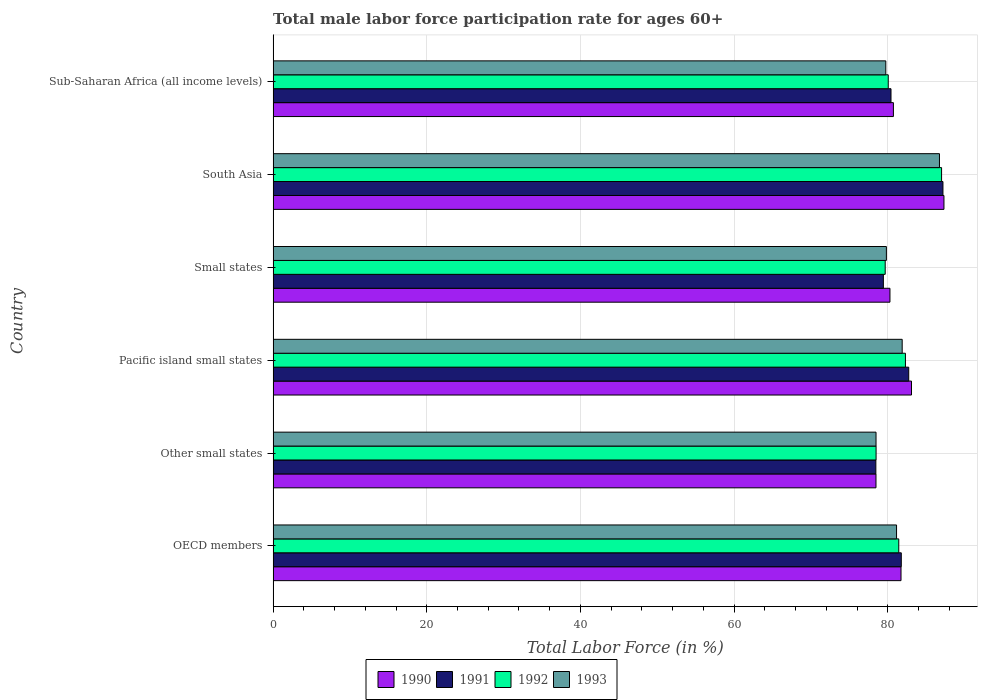How many groups of bars are there?
Provide a short and direct response. 6. Are the number of bars on each tick of the Y-axis equal?
Offer a very short reply. Yes. How many bars are there on the 5th tick from the top?
Make the answer very short. 4. How many bars are there on the 4th tick from the bottom?
Provide a short and direct response. 4. What is the male labor force participation rate in 1990 in Small states?
Keep it short and to the point. 80.28. Across all countries, what is the maximum male labor force participation rate in 1991?
Provide a short and direct response. 87.18. Across all countries, what is the minimum male labor force participation rate in 1992?
Keep it short and to the point. 78.48. In which country was the male labor force participation rate in 1993 maximum?
Offer a very short reply. South Asia. In which country was the male labor force participation rate in 1993 minimum?
Provide a succinct answer. Other small states. What is the total male labor force participation rate in 1991 in the graph?
Give a very brief answer. 489.96. What is the difference between the male labor force participation rate in 1991 in Other small states and that in Small states?
Your response must be concise. -0.98. What is the difference between the male labor force participation rate in 1993 in OECD members and the male labor force participation rate in 1991 in Small states?
Ensure brevity in your answer.  1.71. What is the average male labor force participation rate in 1991 per country?
Offer a terse response. 81.66. What is the difference between the male labor force participation rate in 1991 and male labor force participation rate in 1990 in Other small states?
Keep it short and to the point. -0.02. What is the ratio of the male labor force participation rate in 1993 in Pacific island small states to that in South Asia?
Offer a terse response. 0.94. Is the difference between the male labor force participation rate in 1991 in Other small states and Pacific island small states greater than the difference between the male labor force participation rate in 1990 in Other small states and Pacific island small states?
Give a very brief answer. Yes. What is the difference between the highest and the second highest male labor force participation rate in 1990?
Offer a terse response. 4.22. What is the difference between the highest and the lowest male labor force participation rate in 1991?
Make the answer very short. 8.73. In how many countries, is the male labor force participation rate in 1992 greater than the average male labor force participation rate in 1992 taken over all countries?
Ensure brevity in your answer.  2. Is the sum of the male labor force participation rate in 1990 in Other small states and South Asia greater than the maximum male labor force participation rate in 1991 across all countries?
Your answer should be very brief. Yes. Is it the case that in every country, the sum of the male labor force participation rate in 1992 and male labor force participation rate in 1991 is greater than the sum of male labor force participation rate in 1993 and male labor force participation rate in 1990?
Make the answer very short. No. Is it the case that in every country, the sum of the male labor force participation rate in 1991 and male labor force participation rate in 1990 is greater than the male labor force participation rate in 1993?
Give a very brief answer. Yes. What is the difference between two consecutive major ticks on the X-axis?
Keep it short and to the point. 20. Does the graph contain grids?
Ensure brevity in your answer.  Yes. Where does the legend appear in the graph?
Your response must be concise. Bottom center. How many legend labels are there?
Provide a succinct answer. 4. How are the legend labels stacked?
Your answer should be compact. Horizontal. What is the title of the graph?
Your response must be concise. Total male labor force participation rate for ages 60+. Does "1998" appear as one of the legend labels in the graph?
Your answer should be very brief. No. What is the label or title of the X-axis?
Offer a very short reply. Total Labor Force (in %). What is the label or title of the Y-axis?
Your answer should be compact. Country. What is the Total Labor Force (in %) of 1990 in OECD members?
Make the answer very short. 81.72. What is the Total Labor Force (in %) of 1991 in OECD members?
Offer a terse response. 81.76. What is the Total Labor Force (in %) of 1992 in OECD members?
Offer a terse response. 81.43. What is the Total Labor Force (in %) in 1993 in OECD members?
Offer a terse response. 81.14. What is the Total Labor Force (in %) in 1990 in Other small states?
Provide a succinct answer. 78.46. What is the Total Labor Force (in %) of 1991 in Other small states?
Provide a short and direct response. 78.45. What is the Total Labor Force (in %) in 1992 in Other small states?
Give a very brief answer. 78.48. What is the Total Labor Force (in %) of 1993 in Other small states?
Your answer should be very brief. 78.47. What is the Total Labor Force (in %) in 1990 in Pacific island small states?
Your answer should be compact. 83.09. What is the Total Labor Force (in %) in 1991 in Pacific island small states?
Your response must be concise. 82.72. What is the Total Labor Force (in %) of 1992 in Pacific island small states?
Ensure brevity in your answer.  82.3. What is the Total Labor Force (in %) of 1993 in Pacific island small states?
Offer a terse response. 81.87. What is the Total Labor Force (in %) in 1990 in Small states?
Your answer should be very brief. 80.28. What is the Total Labor Force (in %) in 1991 in Small states?
Give a very brief answer. 79.43. What is the Total Labor Force (in %) of 1992 in Small states?
Offer a very short reply. 79.66. What is the Total Labor Force (in %) of 1993 in Small states?
Give a very brief answer. 79.82. What is the Total Labor Force (in %) of 1990 in South Asia?
Your response must be concise. 87.31. What is the Total Labor Force (in %) in 1991 in South Asia?
Make the answer very short. 87.18. What is the Total Labor Force (in %) of 1992 in South Asia?
Ensure brevity in your answer.  87. What is the Total Labor Force (in %) of 1993 in South Asia?
Your answer should be very brief. 86.73. What is the Total Labor Force (in %) in 1990 in Sub-Saharan Africa (all income levels)?
Offer a terse response. 80.73. What is the Total Labor Force (in %) in 1991 in Sub-Saharan Africa (all income levels)?
Offer a very short reply. 80.42. What is the Total Labor Force (in %) in 1992 in Sub-Saharan Africa (all income levels)?
Offer a terse response. 80.06. What is the Total Labor Force (in %) in 1993 in Sub-Saharan Africa (all income levels)?
Offer a very short reply. 79.74. Across all countries, what is the maximum Total Labor Force (in %) in 1990?
Give a very brief answer. 87.31. Across all countries, what is the maximum Total Labor Force (in %) of 1991?
Provide a short and direct response. 87.18. Across all countries, what is the maximum Total Labor Force (in %) in 1992?
Give a very brief answer. 87. Across all countries, what is the maximum Total Labor Force (in %) in 1993?
Ensure brevity in your answer.  86.73. Across all countries, what is the minimum Total Labor Force (in %) in 1990?
Give a very brief answer. 78.46. Across all countries, what is the minimum Total Labor Force (in %) of 1991?
Give a very brief answer. 78.45. Across all countries, what is the minimum Total Labor Force (in %) of 1992?
Offer a very short reply. 78.48. Across all countries, what is the minimum Total Labor Force (in %) in 1993?
Make the answer very short. 78.47. What is the total Total Labor Force (in %) in 1990 in the graph?
Ensure brevity in your answer.  491.6. What is the total Total Labor Force (in %) of 1991 in the graph?
Provide a short and direct response. 489.96. What is the total Total Labor Force (in %) in 1992 in the graph?
Your answer should be compact. 488.93. What is the total Total Labor Force (in %) of 1993 in the graph?
Ensure brevity in your answer.  487.77. What is the difference between the Total Labor Force (in %) in 1990 in OECD members and that in Other small states?
Ensure brevity in your answer.  3.26. What is the difference between the Total Labor Force (in %) of 1991 in OECD members and that in Other small states?
Provide a short and direct response. 3.31. What is the difference between the Total Labor Force (in %) of 1992 in OECD members and that in Other small states?
Provide a short and direct response. 2.95. What is the difference between the Total Labor Force (in %) in 1993 in OECD members and that in Other small states?
Offer a very short reply. 2.67. What is the difference between the Total Labor Force (in %) of 1990 in OECD members and that in Pacific island small states?
Provide a succinct answer. -1.36. What is the difference between the Total Labor Force (in %) in 1991 in OECD members and that in Pacific island small states?
Your answer should be very brief. -0.97. What is the difference between the Total Labor Force (in %) of 1992 in OECD members and that in Pacific island small states?
Make the answer very short. -0.87. What is the difference between the Total Labor Force (in %) of 1993 in OECD members and that in Pacific island small states?
Keep it short and to the point. -0.73. What is the difference between the Total Labor Force (in %) of 1990 in OECD members and that in Small states?
Offer a very short reply. 1.44. What is the difference between the Total Labor Force (in %) in 1991 in OECD members and that in Small states?
Keep it short and to the point. 2.33. What is the difference between the Total Labor Force (in %) in 1992 in OECD members and that in Small states?
Offer a terse response. 1.77. What is the difference between the Total Labor Force (in %) of 1993 in OECD members and that in Small states?
Your answer should be compact. 1.32. What is the difference between the Total Labor Force (in %) of 1990 in OECD members and that in South Asia?
Ensure brevity in your answer.  -5.59. What is the difference between the Total Labor Force (in %) of 1991 in OECD members and that in South Asia?
Your response must be concise. -5.42. What is the difference between the Total Labor Force (in %) of 1992 in OECD members and that in South Asia?
Your answer should be compact. -5.57. What is the difference between the Total Labor Force (in %) of 1993 in OECD members and that in South Asia?
Offer a terse response. -5.59. What is the difference between the Total Labor Force (in %) of 1990 in OECD members and that in Sub-Saharan Africa (all income levels)?
Your answer should be very brief. 0.99. What is the difference between the Total Labor Force (in %) of 1991 in OECD members and that in Sub-Saharan Africa (all income levels)?
Give a very brief answer. 1.34. What is the difference between the Total Labor Force (in %) of 1992 in OECD members and that in Sub-Saharan Africa (all income levels)?
Keep it short and to the point. 1.37. What is the difference between the Total Labor Force (in %) of 1993 in OECD members and that in Sub-Saharan Africa (all income levels)?
Your answer should be compact. 1.4. What is the difference between the Total Labor Force (in %) of 1990 in Other small states and that in Pacific island small states?
Provide a short and direct response. -4.62. What is the difference between the Total Labor Force (in %) of 1991 in Other small states and that in Pacific island small states?
Offer a terse response. -4.28. What is the difference between the Total Labor Force (in %) in 1992 in Other small states and that in Pacific island small states?
Your answer should be compact. -3.82. What is the difference between the Total Labor Force (in %) in 1993 in Other small states and that in Pacific island small states?
Make the answer very short. -3.4. What is the difference between the Total Labor Force (in %) of 1990 in Other small states and that in Small states?
Your answer should be compact. -1.82. What is the difference between the Total Labor Force (in %) in 1991 in Other small states and that in Small states?
Offer a terse response. -0.98. What is the difference between the Total Labor Force (in %) in 1992 in Other small states and that in Small states?
Offer a very short reply. -1.19. What is the difference between the Total Labor Force (in %) of 1993 in Other small states and that in Small states?
Give a very brief answer. -1.35. What is the difference between the Total Labor Force (in %) in 1990 in Other small states and that in South Asia?
Your answer should be compact. -8.85. What is the difference between the Total Labor Force (in %) in 1991 in Other small states and that in South Asia?
Give a very brief answer. -8.73. What is the difference between the Total Labor Force (in %) of 1992 in Other small states and that in South Asia?
Your answer should be compact. -8.52. What is the difference between the Total Labor Force (in %) of 1993 in Other small states and that in South Asia?
Give a very brief answer. -8.26. What is the difference between the Total Labor Force (in %) in 1990 in Other small states and that in Sub-Saharan Africa (all income levels)?
Offer a very short reply. -2.27. What is the difference between the Total Labor Force (in %) of 1991 in Other small states and that in Sub-Saharan Africa (all income levels)?
Offer a very short reply. -1.97. What is the difference between the Total Labor Force (in %) in 1992 in Other small states and that in Sub-Saharan Africa (all income levels)?
Provide a succinct answer. -1.58. What is the difference between the Total Labor Force (in %) of 1993 in Other small states and that in Sub-Saharan Africa (all income levels)?
Keep it short and to the point. -1.27. What is the difference between the Total Labor Force (in %) of 1990 in Pacific island small states and that in Small states?
Provide a short and direct response. 2.8. What is the difference between the Total Labor Force (in %) in 1991 in Pacific island small states and that in Small states?
Ensure brevity in your answer.  3.3. What is the difference between the Total Labor Force (in %) of 1992 in Pacific island small states and that in Small states?
Ensure brevity in your answer.  2.63. What is the difference between the Total Labor Force (in %) in 1993 in Pacific island small states and that in Small states?
Keep it short and to the point. 2.05. What is the difference between the Total Labor Force (in %) of 1990 in Pacific island small states and that in South Asia?
Provide a short and direct response. -4.22. What is the difference between the Total Labor Force (in %) in 1991 in Pacific island small states and that in South Asia?
Give a very brief answer. -4.46. What is the difference between the Total Labor Force (in %) in 1992 in Pacific island small states and that in South Asia?
Offer a terse response. -4.7. What is the difference between the Total Labor Force (in %) of 1993 in Pacific island small states and that in South Asia?
Ensure brevity in your answer.  -4.85. What is the difference between the Total Labor Force (in %) of 1990 in Pacific island small states and that in Sub-Saharan Africa (all income levels)?
Offer a very short reply. 2.35. What is the difference between the Total Labor Force (in %) in 1991 in Pacific island small states and that in Sub-Saharan Africa (all income levels)?
Offer a very short reply. 2.31. What is the difference between the Total Labor Force (in %) in 1992 in Pacific island small states and that in Sub-Saharan Africa (all income levels)?
Give a very brief answer. 2.24. What is the difference between the Total Labor Force (in %) in 1993 in Pacific island small states and that in Sub-Saharan Africa (all income levels)?
Make the answer very short. 2.13. What is the difference between the Total Labor Force (in %) of 1990 in Small states and that in South Asia?
Your answer should be compact. -7.03. What is the difference between the Total Labor Force (in %) in 1991 in Small states and that in South Asia?
Your answer should be very brief. -7.75. What is the difference between the Total Labor Force (in %) in 1992 in Small states and that in South Asia?
Offer a very short reply. -7.34. What is the difference between the Total Labor Force (in %) of 1993 in Small states and that in South Asia?
Offer a very short reply. -6.91. What is the difference between the Total Labor Force (in %) in 1990 in Small states and that in Sub-Saharan Africa (all income levels)?
Keep it short and to the point. -0.45. What is the difference between the Total Labor Force (in %) in 1991 in Small states and that in Sub-Saharan Africa (all income levels)?
Offer a terse response. -0.99. What is the difference between the Total Labor Force (in %) of 1992 in Small states and that in Sub-Saharan Africa (all income levels)?
Provide a succinct answer. -0.4. What is the difference between the Total Labor Force (in %) of 1993 in Small states and that in Sub-Saharan Africa (all income levels)?
Ensure brevity in your answer.  0.08. What is the difference between the Total Labor Force (in %) in 1990 in South Asia and that in Sub-Saharan Africa (all income levels)?
Give a very brief answer. 6.58. What is the difference between the Total Labor Force (in %) of 1991 in South Asia and that in Sub-Saharan Africa (all income levels)?
Ensure brevity in your answer.  6.76. What is the difference between the Total Labor Force (in %) of 1992 in South Asia and that in Sub-Saharan Africa (all income levels)?
Provide a succinct answer. 6.94. What is the difference between the Total Labor Force (in %) in 1993 in South Asia and that in Sub-Saharan Africa (all income levels)?
Provide a short and direct response. 6.99. What is the difference between the Total Labor Force (in %) in 1990 in OECD members and the Total Labor Force (in %) in 1991 in Other small states?
Your answer should be very brief. 3.27. What is the difference between the Total Labor Force (in %) of 1990 in OECD members and the Total Labor Force (in %) of 1992 in Other small states?
Ensure brevity in your answer.  3.24. What is the difference between the Total Labor Force (in %) of 1990 in OECD members and the Total Labor Force (in %) of 1993 in Other small states?
Provide a succinct answer. 3.25. What is the difference between the Total Labor Force (in %) in 1991 in OECD members and the Total Labor Force (in %) in 1992 in Other small states?
Offer a terse response. 3.28. What is the difference between the Total Labor Force (in %) in 1991 in OECD members and the Total Labor Force (in %) in 1993 in Other small states?
Your response must be concise. 3.29. What is the difference between the Total Labor Force (in %) in 1992 in OECD members and the Total Labor Force (in %) in 1993 in Other small states?
Offer a terse response. 2.96. What is the difference between the Total Labor Force (in %) of 1990 in OECD members and the Total Labor Force (in %) of 1991 in Pacific island small states?
Make the answer very short. -1. What is the difference between the Total Labor Force (in %) in 1990 in OECD members and the Total Labor Force (in %) in 1992 in Pacific island small states?
Ensure brevity in your answer.  -0.58. What is the difference between the Total Labor Force (in %) in 1990 in OECD members and the Total Labor Force (in %) in 1993 in Pacific island small states?
Give a very brief answer. -0.15. What is the difference between the Total Labor Force (in %) of 1991 in OECD members and the Total Labor Force (in %) of 1992 in Pacific island small states?
Provide a succinct answer. -0.54. What is the difference between the Total Labor Force (in %) in 1991 in OECD members and the Total Labor Force (in %) in 1993 in Pacific island small states?
Offer a terse response. -0.12. What is the difference between the Total Labor Force (in %) in 1992 in OECD members and the Total Labor Force (in %) in 1993 in Pacific island small states?
Keep it short and to the point. -0.44. What is the difference between the Total Labor Force (in %) of 1990 in OECD members and the Total Labor Force (in %) of 1991 in Small states?
Give a very brief answer. 2.29. What is the difference between the Total Labor Force (in %) in 1990 in OECD members and the Total Labor Force (in %) in 1992 in Small states?
Offer a terse response. 2.06. What is the difference between the Total Labor Force (in %) of 1990 in OECD members and the Total Labor Force (in %) of 1993 in Small states?
Provide a succinct answer. 1.9. What is the difference between the Total Labor Force (in %) in 1991 in OECD members and the Total Labor Force (in %) in 1992 in Small states?
Make the answer very short. 2.09. What is the difference between the Total Labor Force (in %) of 1991 in OECD members and the Total Labor Force (in %) of 1993 in Small states?
Your response must be concise. 1.94. What is the difference between the Total Labor Force (in %) of 1992 in OECD members and the Total Labor Force (in %) of 1993 in Small states?
Make the answer very short. 1.61. What is the difference between the Total Labor Force (in %) of 1990 in OECD members and the Total Labor Force (in %) of 1991 in South Asia?
Offer a terse response. -5.46. What is the difference between the Total Labor Force (in %) in 1990 in OECD members and the Total Labor Force (in %) in 1992 in South Asia?
Make the answer very short. -5.28. What is the difference between the Total Labor Force (in %) in 1990 in OECD members and the Total Labor Force (in %) in 1993 in South Asia?
Your answer should be compact. -5.01. What is the difference between the Total Labor Force (in %) in 1991 in OECD members and the Total Labor Force (in %) in 1992 in South Asia?
Your answer should be compact. -5.24. What is the difference between the Total Labor Force (in %) in 1991 in OECD members and the Total Labor Force (in %) in 1993 in South Asia?
Offer a terse response. -4.97. What is the difference between the Total Labor Force (in %) in 1992 in OECD members and the Total Labor Force (in %) in 1993 in South Asia?
Keep it short and to the point. -5.3. What is the difference between the Total Labor Force (in %) in 1990 in OECD members and the Total Labor Force (in %) in 1991 in Sub-Saharan Africa (all income levels)?
Offer a terse response. 1.3. What is the difference between the Total Labor Force (in %) in 1990 in OECD members and the Total Labor Force (in %) in 1992 in Sub-Saharan Africa (all income levels)?
Your response must be concise. 1.66. What is the difference between the Total Labor Force (in %) in 1990 in OECD members and the Total Labor Force (in %) in 1993 in Sub-Saharan Africa (all income levels)?
Your answer should be very brief. 1.98. What is the difference between the Total Labor Force (in %) of 1991 in OECD members and the Total Labor Force (in %) of 1992 in Sub-Saharan Africa (all income levels)?
Offer a very short reply. 1.7. What is the difference between the Total Labor Force (in %) in 1991 in OECD members and the Total Labor Force (in %) in 1993 in Sub-Saharan Africa (all income levels)?
Your response must be concise. 2.02. What is the difference between the Total Labor Force (in %) in 1992 in OECD members and the Total Labor Force (in %) in 1993 in Sub-Saharan Africa (all income levels)?
Your answer should be very brief. 1.69. What is the difference between the Total Labor Force (in %) of 1990 in Other small states and the Total Labor Force (in %) of 1991 in Pacific island small states?
Your answer should be very brief. -4.26. What is the difference between the Total Labor Force (in %) in 1990 in Other small states and the Total Labor Force (in %) in 1992 in Pacific island small states?
Your response must be concise. -3.83. What is the difference between the Total Labor Force (in %) of 1990 in Other small states and the Total Labor Force (in %) of 1993 in Pacific island small states?
Your response must be concise. -3.41. What is the difference between the Total Labor Force (in %) in 1991 in Other small states and the Total Labor Force (in %) in 1992 in Pacific island small states?
Offer a terse response. -3.85. What is the difference between the Total Labor Force (in %) of 1991 in Other small states and the Total Labor Force (in %) of 1993 in Pacific island small states?
Keep it short and to the point. -3.43. What is the difference between the Total Labor Force (in %) in 1992 in Other small states and the Total Labor Force (in %) in 1993 in Pacific island small states?
Offer a very short reply. -3.4. What is the difference between the Total Labor Force (in %) in 1990 in Other small states and the Total Labor Force (in %) in 1991 in Small states?
Your answer should be very brief. -0.96. What is the difference between the Total Labor Force (in %) in 1990 in Other small states and the Total Labor Force (in %) in 1992 in Small states?
Provide a short and direct response. -1.2. What is the difference between the Total Labor Force (in %) in 1990 in Other small states and the Total Labor Force (in %) in 1993 in Small states?
Your answer should be compact. -1.36. What is the difference between the Total Labor Force (in %) of 1991 in Other small states and the Total Labor Force (in %) of 1992 in Small states?
Make the answer very short. -1.22. What is the difference between the Total Labor Force (in %) in 1991 in Other small states and the Total Labor Force (in %) in 1993 in Small states?
Ensure brevity in your answer.  -1.37. What is the difference between the Total Labor Force (in %) in 1992 in Other small states and the Total Labor Force (in %) in 1993 in Small states?
Offer a very short reply. -1.34. What is the difference between the Total Labor Force (in %) of 1990 in Other small states and the Total Labor Force (in %) of 1991 in South Asia?
Provide a short and direct response. -8.72. What is the difference between the Total Labor Force (in %) in 1990 in Other small states and the Total Labor Force (in %) in 1992 in South Asia?
Ensure brevity in your answer.  -8.54. What is the difference between the Total Labor Force (in %) of 1990 in Other small states and the Total Labor Force (in %) of 1993 in South Asia?
Make the answer very short. -8.26. What is the difference between the Total Labor Force (in %) in 1991 in Other small states and the Total Labor Force (in %) in 1992 in South Asia?
Your response must be concise. -8.55. What is the difference between the Total Labor Force (in %) in 1991 in Other small states and the Total Labor Force (in %) in 1993 in South Asia?
Make the answer very short. -8.28. What is the difference between the Total Labor Force (in %) in 1992 in Other small states and the Total Labor Force (in %) in 1993 in South Asia?
Provide a succinct answer. -8.25. What is the difference between the Total Labor Force (in %) in 1990 in Other small states and the Total Labor Force (in %) in 1991 in Sub-Saharan Africa (all income levels)?
Offer a very short reply. -1.96. What is the difference between the Total Labor Force (in %) in 1990 in Other small states and the Total Labor Force (in %) in 1992 in Sub-Saharan Africa (all income levels)?
Your answer should be compact. -1.6. What is the difference between the Total Labor Force (in %) in 1990 in Other small states and the Total Labor Force (in %) in 1993 in Sub-Saharan Africa (all income levels)?
Your answer should be compact. -1.28. What is the difference between the Total Labor Force (in %) in 1991 in Other small states and the Total Labor Force (in %) in 1992 in Sub-Saharan Africa (all income levels)?
Make the answer very short. -1.61. What is the difference between the Total Labor Force (in %) of 1991 in Other small states and the Total Labor Force (in %) of 1993 in Sub-Saharan Africa (all income levels)?
Give a very brief answer. -1.29. What is the difference between the Total Labor Force (in %) in 1992 in Other small states and the Total Labor Force (in %) in 1993 in Sub-Saharan Africa (all income levels)?
Offer a very short reply. -1.26. What is the difference between the Total Labor Force (in %) of 1990 in Pacific island small states and the Total Labor Force (in %) of 1991 in Small states?
Your answer should be very brief. 3.66. What is the difference between the Total Labor Force (in %) in 1990 in Pacific island small states and the Total Labor Force (in %) in 1992 in Small states?
Your response must be concise. 3.42. What is the difference between the Total Labor Force (in %) in 1990 in Pacific island small states and the Total Labor Force (in %) in 1993 in Small states?
Provide a succinct answer. 3.27. What is the difference between the Total Labor Force (in %) of 1991 in Pacific island small states and the Total Labor Force (in %) of 1992 in Small states?
Your answer should be compact. 3.06. What is the difference between the Total Labor Force (in %) in 1991 in Pacific island small states and the Total Labor Force (in %) in 1993 in Small states?
Offer a very short reply. 2.91. What is the difference between the Total Labor Force (in %) of 1992 in Pacific island small states and the Total Labor Force (in %) of 1993 in Small states?
Offer a terse response. 2.48. What is the difference between the Total Labor Force (in %) in 1990 in Pacific island small states and the Total Labor Force (in %) in 1991 in South Asia?
Offer a terse response. -4.09. What is the difference between the Total Labor Force (in %) of 1990 in Pacific island small states and the Total Labor Force (in %) of 1992 in South Asia?
Your answer should be very brief. -3.91. What is the difference between the Total Labor Force (in %) in 1990 in Pacific island small states and the Total Labor Force (in %) in 1993 in South Asia?
Provide a short and direct response. -3.64. What is the difference between the Total Labor Force (in %) in 1991 in Pacific island small states and the Total Labor Force (in %) in 1992 in South Asia?
Offer a very short reply. -4.28. What is the difference between the Total Labor Force (in %) in 1991 in Pacific island small states and the Total Labor Force (in %) in 1993 in South Asia?
Offer a very short reply. -4. What is the difference between the Total Labor Force (in %) of 1992 in Pacific island small states and the Total Labor Force (in %) of 1993 in South Asia?
Your answer should be compact. -4.43. What is the difference between the Total Labor Force (in %) of 1990 in Pacific island small states and the Total Labor Force (in %) of 1991 in Sub-Saharan Africa (all income levels)?
Your answer should be very brief. 2.67. What is the difference between the Total Labor Force (in %) of 1990 in Pacific island small states and the Total Labor Force (in %) of 1992 in Sub-Saharan Africa (all income levels)?
Your answer should be compact. 3.03. What is the difference between the Total Labor Force (in %) in 1990 in Pacific island small states and the Total Labor Force (in %) in 1993 in Sub-Saharan Africa (all income levels)?
Your answer should be very brief. 3.35. What is the difference between the Total Labor Force (in %) of 1991 in Pacific island small states and the Total Labor Force (in %) of 1992 in Sub-Saharan Africa (all income levels)?
Ensure brevity in your answer.  2.66. What is the difference between the Total Labor Force (in %) of 1991 in Pacific island small states and the Total Labor Force (in %) of 1993 in Sub-Saharan Africa (all income levels)?
Offer a terse response. 2.98. What is the difference between the Total Labor Force (in %) of 1992 in Pacific island small states and the Total Labor Force (in %) of 1993 in Sub-Saharan Africa (all income levels)?
Provide a short and direct response. 2.56. What is the difference between the Total Labor Force (in %) of 1990 in Small states and the Total Labor Force (in %) of 1991 in South Asia?
Offer a terse response. -6.9. What is the difference between the Total Labor Force (in %) in 1990 in Small states and the Total Labor Force (in %) in 1992 in South Asia?
Offer a very short reply. -6.72. What is the difference between the Total Labor Force (in %) of 1990 in Small states and the Total Labor Force (in %) of 1993 in South Asia?
Your response must be concise. -6.44. What is the difference between the Total Labor Force (in %) in 1991 in Small states and the Total Labor Force (in %) in 1992 in South Asia?
Your answer should be compact. -7.57. What is the difference between the Total Labor Force (in %) of 1991 in Small states and the Total Labor Force (in %) of 1993 in South Asia?
Your response must be concise. -7.3. What is the difference between the Total Labor Force (in %) in 1992 in Small states and the Total Labor Force (in %) in 1993 in South Asia?
Provide a short and direct response. -7.06. What is the difference between the Total Labor Force (in %) in 1990 in Small states and the Total Labor Force (in %) in 1991 in Sub-Saharan Africa (all income levels)?
Your response must be concise. -0.14. What is the difference between the Total Labor Force (in %) in 1990 in Small states and the Total Labor Force (in %) in 1992 in Sub-Saharan Africa (all income levels)?
Offer a very short reply. 0.22. What is the difference between the Total Labor Force (in %) in 1990 in Small states and the Total Labor Force (in %) in 1993 in Sub-Saharan Africa (all income levels)?
Give a very brief answer. 0.54. What is the difference between the Total Labor Force (in %) of 1991 in Small states and the Total Labor Force (in %) of 1992 in Sub-Saharan Africa (all income levels)?
Provide a short and direct response. -0.63. What is the difference between the Total Labor Force (in %) in 1991 in Small states and the Total Labor Force (in %) in 1993 in Sub-Saharan Africa (all income levels)?
Offer a terse response. -0.31. What is the difference between the Total Labor Force (in %) of 1992 in Small states and the Total Labor Force (in %) of 1993 in Sub-Saharan Africa (all income levels)?
Provide a short and direct response. -0.08. What is the difference between the Total Labor Force (in %) of 1990 in South Asia and the Total Labor Force (in %) of 1991 in Sub-Saharan Africa (all income levels)?
Your answer should be compact. 6.89. What is the difference between the Total Labor Force (in %) in 1990 in South Asia and the Total Labor Force (in %) in 1992 in Sub-Saharan Africa (all income levels)?
Provide a succinct answer. 7.25. What is the difference between the Total Labor Force (in %) in 1990 in South Asia and the Total Labor Force (in %) in 1993 in Sub-Saharan Africa (all income levels)?
Ensure brevity in your answer.  7.57. What is the difference between the Total Labor Force (in %) of 1991 in South Asia and the Total Labor Force (in %) of 1992 in Sub-Saharan Africa (all income levels)?
Offer a very short reply. 7.12. What is the difference between the Total Labor Force (in %) of 1991 in South Asia and the Total Labor Force (in %) of 1993 in Sub-Saharan Africa (all income levels)?
Offer a terse response. 7.44. What is the difference between the Total Labor Force (in %) in 1992 in South Asia and the Total Labor Force (in %) in 1993 in Sub-Saharan Africa (all income levels)?
Give a very brief answer. 7.26. What is the average Total Labor Force (in %) of 1990 per country?
Your response must be concise. 81.93. What is the average Total Labor Force (in %) in 1991 per country?
Ensure brevity in your answer.  81.66. What is the average Total Labor Force (in %) of 1992 per country?
Make the answer very short. 81.49. What is the average Total Labor Force (in %) of 1993 per country?
Give a very brief answer. 81.3. What is the difference between the Total Labor Force (in %) in 1990 and Total Labor Force (in %) in 1991 in OECD members?
Provide a succinct answer. -0.04. What is the difference between the Total Labor Force (in %) in 1990 and Total Labor Force (in %) in 1992 in OECD members?
Give a very brief answer. 0.29. What is the difference between the Total Labor Force (in %) of 1990 and Total Labor Force (in %) of 1993 in OECD members?
Your answer should be very brief. 0.58. What is the difference between the Total Labor Force (in %) in 1991 and Total Labor Force (in %) in 1992 in OECD members?
Your answer should be compact. 0.33. What is the difference between the Total Labor Force (in %) of 1991 and Total Labor Force (in %) of 1993 in OECD members?
Your response must be concise. 0.62. What is the difference between the Total Labor Force (in %) of 1992 and Total Labor Force (in %) of 1993 in OECD members?
Your response must be concise. 0.29. What is the difference between the Total Labor Force (in %) in 1990 and Total Labor Force (in %) in 1991 in Other small states?
Offer a terse response. 0.02. What is the difference between the Total Labor Force (in %) in 1990 and Total Labor Force (in %) in 1992 in Other small states?
Make the answer very short. -0.01. What is the difference between the Total Labor Force (in %) in 1990 and Total Labor Force (in %) in 1993 in Other small states?
Your answer should be compact. -0.01. What is the difference between the Total Labor Force (in %) in 1991 and Total Labor Force (in %) in 1992 in Other small states?
Make the answer very short. -0.03. What is the difference between the Total Labor Force (in %) of 1991 and Total Labor Force (in %) of 1993 in Other small states?
Make the answer very short. -0.02. What is the difference between the Total Labor Force (in %) in 1992 and Total Labor Force (in %) in 1993 in Other small states?
Offer a very short reply. 0.01. What is the difference between the Total Labor Force (in %) of 1990 and Total Labor Force (in %) of 1991 in Pacific island small states?
Make the answer very short. 0.36. What is the difference between the Total Labor Force (in %) of 1990 and Total Labor Force (in %) of 1992 in Pacific island small states?
Your answer should be compact. 0.79. What is the difference between the Total Labor Force (in %) of 1990 and Total Labor Force (in %) of 1993 in Pacific island small states?
Your answer should be compact. 1.21. What is the difference between the Total Labor Force (in %) in 1991 and Total Labor Force (in %) in 1992 in Pacific island small states?
Your answer should be very brief. 0.43. What is the difference between the Total Labor Force (in %) in 1991 and Total Labor Force (in %) in 1993 in Pacific island small states?
Provide a short and direct response. 0.85. What is the difference between the Total Labor Force (in %) in 1992 and Total Labor Force (in %) in 1993 in Pacific island small states?
Provide a short and direct response. 0.42. What is the difference between the Total Labor Force (in %) in 1990 and Total Labor Force (in %) in 1991 in Small states?
Keep it short and to the point. 0.86. What is the difference between the Total Labor Force (in %) of 1990 and Total Labor Force (in %) of 1992 in Small states?
Ensure brevity in your answer.  0.62. What is the difference between the Total Labor Force (in %) of 1990 and Total Labor Force (in %) of 1993 in Small states?
Offer a very short reply. 0.46. What is the difference between the Total Labor Force (in %) in 1991 and Total Labor Force (in %) in 1992 in Small states?
Your answer should be very brief. -0.24. What is the difference between the Total Labor Force (in %) in 1991 and Total Labor Force (in %) in 1993 in Small states?
Keep it short and to the point. -0.39. What is the difference between the Total Labor Force (in %) in 1992 and Total Labor Force (in %) in 1993 in Small states?
Ensure brevity in your answer.  -0.15. What is the difference between the Total Labor Force (in %) of 1990 and Total Labor Force (in %) of 1991 in South Asia?
Your response must be concise. 0.13. What is the difference between the Total Labor Force (in %) of 1990 and Total Labor Force (in %) of 1992 in South Asia?
Your answer should be compact. 0.31. What is the difference between the Total Labor Force (in %) in 1990 and Total Labor Force (in %) in 1993 in South Asia?
Your answer should be compact. 0.58. What is the difference between the Total Labor Force (in %) of 1991 and Total Labor Force (in %) of 1992 in South Asia?
Make the answer very short. 0.18. What is the difference between the Total Labor Force (in %) of 1991 and Total Labor Force (in %) of 1993 in South Asia?
Provide a succinct answer. 0.45. What is the difference between the Total Labor Force (in %) in 1992 and Total Labor Force (in %) in 1993 in South Asia?
Provide a succinct answer. 0.27. What is the difference between the Total Labor Force (in %) in 1990 and Total Labor Force (in %) in 1991 in Sub-Saharan Africa (all income levels)?
Provide a short and direct response. 0.31. What is the difference between the Total Labor Force (in %) in 1990 and Total Labor Force (in %) in 1992 in Sub-Saharan Africa (all income levels)?
Provide a succinct answer. 0.67. What is the difference between the Total Labor Force (in %) of 1990 and Total Labor Force (in %) of 1993 in Sub-Saharan Africa (all income levels)?
Make the answer very short. 0.99. What is the difference between the Total Labor Force (in %) of 1991 and Total Labor Force (in %) of 1992 in Sub-Saharan Africa (all income levels)?
Provide a succinct answer. 0.36. What is the difference between the Total Labor Force (in %) of 1991 and Total Labor Force (in %) of 1993 in Sub-Saharan Africa (all income levels)?
Ensure brevity in your answer.  0.68. What is the difference between the Total Labor Force (in %) of 1992 and Total Labor Force (in %) of 1993 in Sub-Saharan Africa (all income levels)?
Provide a succinct answer. 0.32. What is the ratio of the Total Labor Force (in %) in 1990 in OECD members to that in Other small states?
Provide a succinct answer. 1.04. What is the ratio of the Total Labor Force (in %) of 1991 in OECD members to that in Other small states?
Provide a succinct answer. 1.04. What is the ratio of the Total Labor Force (in %) in 1992 in OECD members to that in Other small states?
Ensure brevity in your answer.  1.04. What is the ratio of the Total Labor Force (in %) in 1993 in OECD members to that in Other small states?
Make the answer very short. 1.03. What is the ratio of the Total Labor Force (in %) in 1990 in OECD members to that in Pacific island small states?
Keep it short and to the point. 0.98. What is the ratio of the Total Labor Force (in %) in 1991 in OECD members to that in Pacific island small states?
Offer a terse response. 0.99. What is the ratio of the Total Labor Force (in %) of 1992 in OECD members to that in Pacific island small states?
Your response must be concise. 0.99. What is the ratio of the Total Labor Force (in %) in 1990 in OECD members to that in Small states?
Make the answer very short. 1.02. What is the ratio of the Total Labor Force (in %) of 1991 in OECD members to that in Small states?
Your response must be concise. 1.03. What is the ratio of the Total Labor Force (in %) in 1992 in OECD members to that in Small states?
Provide a succinct answer. 1.02. What is the ratio of the Total Labor Force (in %) in 1993 in OECD members to that in Small states?
Your response must be concise. 1.02. What is the ratio of the Total Labor Force (in %) in 1990 in OECD members to that in South Asia?
Provide a succinct answer. 0.94. What is the ratio of the Total Labor Force (in %) of 1991 in OECD members to that in South Asia?
Offer a very short reply. 0.94. What is the ratio of the Total Labor Force (in %) in 1992 in OECD members to that in South Asia?
Offer a very short reply. 0.94. What is the ratio of the Total Labor Force (in %) in 1993 in OECD members to that in South Asia?
Ensure brevity in your answer.  0.94. What is the ratio of the Total Labor Force (in %) in 1990 in OECD members to that in Sub-Saharan Africa (all income levels)?
Provide a short and direct response. 1.01. What is the ratio of the Total Labor Force (in %) in 1991 in OECD members to that in Sub-Saharan Africa (all income levels)?
Offer a terse response. 1.02. What is the ratio of the Total Labor Force (in %) of 1992 in OECD members to that in Sub-Saharan Africa (all income levels)?
Keep it short and to the point. 1.02. What is the ratio of the Total Labor Force (in %) of 1993 in OECD members to that in Sub-Saharan Africa (all income levels)?
Provide a short and direct response. 1.02. What is the ratio of the Total Labor Force (in %) in 1991 in Other small states to that in Pacific island small states?
Make the answer very short. 0.95. What is the ratio of the Total Labor Force (in %) of 1992 in Other small states to that in Pacific island small states?
Make the answer very short. 0.95. What is the ratio of the Total Labor Force (in %) of 1993 in Other small states to that in Pacific island small states?
Your answer should be compact. 0.96. What is the ratio of the Total Labor Force (in %) in 1990 in Other small states to that in Small states?
Provide a short and direct response. 0.98. What is the ratio of the Total Labor Force (in %) of 1991 in Other small states to that in Small states?
Your answer should be compact. 0.99. What is the ratio of the Total Labor Force (in %) of 1992 in Other small states to that in Small states?
Give a very brief answer. 0.99. What is the ratio of the Total Labor Force (in %) of 1993 in Other small states to that in Small states?
Make the answer very short. 0.98. What is the ratio of the Total Labor Force (in %) of 1990 in Other small states to that in South Asia?
Your response must be concise. 0.9. What is the ratio of the Total Labor Force (in %) in 1991 in Other small states to that in South Asia?
Give a very brief answer. 0.9. What is the ratio of the Total Labor Force (in %) of 1992 in Other small states to that in South Asia?
Offer a terse response. 0.9. What is the ratio of the Total Labor Force (in %) of 1993 in Other small states to that in South Asia?
Provide a succinct answer. 0.9. What is the ratio of the Total Labor Force (in %) of 1990 in Other small states to that in Sub-Saharan Africa (all income levels)?
Offer a terse response. 0.97. What is the ratio of the Total Labor Force (in %) of 1991 in Other small states to that in Sub-Saharan Africa (all income levels)?
Your response must be concise. 0.98. What is the ratio of the Total Labor Force (in %) in 1992 in Other small states to that in Sub-Saharan Africa (all income levels)?
Give a very brief answer. 0.98. What is the ratio of the Total Labor Force (in %) in 1993 in Other small states to that in Sub-Saharan Africa (all income levels)?
Your answer should be compact. 0.98. What is the ratio of the Total Labor Force (in %) in 1990 in Pacific island small states to that in Small states?
Give a very brief answer. 1.03. What is the ratio of the Total Labor Force (in %) of 1991 in Pacific island small states to that in Small states?
Offer a very short reply. 1.04. What is the ratio of the Total Labor Force (in %) in 1992 in Pacific island small states to that in Small states?
Your answer should be very brief. 1.03. What is the ratio of the Total Labor Force (in %) of 1993 in Pacific island small states to that in Small states?
Provide a succinct answer. 1.03. What is the ratio of the Total Labor Force (in %) in 1990 in Pacific island small states to that in South Asia?
Provide a succinct answer. 0.95. What is the ratio of the Total Labor Force (in %) in 1991 in Pacific island small states to that in South Asia?
Offer a very short reply. 0.95. What is the ratio of the Total Labor Force (in %) of 1992 in Pacific island small states to that in South Asia?
Provide a short and direct response. 0.95. What is the ratio of the Total Labor Force (in %) of 1993 in Pacific island small states to that in South Asia?
Your response must be concise. 0.94. What is the ratio of the Total Labor Force (in %) of 1990 in Pacific island small states to that in Sub-Saharan Africa (all income levels)?
Make the answer very short. 1.03. What is the ratio of the Total Labor Force (in %) in 1991 in Pacific island small states to that in Sub-Saharan Africa (all income levels)?
Provide a succinct answer. 1.03. What is the ratio of the Total Labor Force (in %) in 1992 in Pacific island small states to that in Sub-Saharan Africa (all income levels)?
Your answer should be compact. 1.03. What is the ratio of the Total Labor Force (in %) of 1993 in Pacific island small states to that in Sub-Saharan Africa (all income levels)?
Offer a very short reply. 1.03. What is the ratio of the Total Labor Force (in %) of 1990 in Small states to that in South Asia?
Your answer should be compact. 0.92. What is the ratio of the Total Labor Force (in %) of 1991 in Small states to that in South Asia?
Your answer should be compact. 0.91. What is the ratio of the Total Labor Force (in %) of 1992 in Small states to that in South Asia?
Your answer should be very brief. 0.92. What is the ratio of the Total Labor Force (in %) of 1993 in Small states to that in South Asia?
Keep it short and to the point. 0.92. What is the ratio of the Total Labor Force (in %) in 1991 in Small states to that in Sub-Saharan Africa (all income levels)?
Give a very brief answer. 0.99. What is the ratio of the Total Labor Force (in %) in 1990 in South Asia to that in Sub-Saharan Africa (all income levels)?
Give a very brief answer. 1.08. What is the ratio of the Total Labor Force (in %) in 1991 in South Asia to that in Sub-Saharan Africa (all income levels)?
Your answer should be compact. 1.08. What is the ratio of the Total Labor Force (in %) in 1992 in South Asia to that in Sub-Saharan Africa (all income levels)?
Provide a succinct answer. 1.09. What is the ratio of the Total Labor Force (in %) in 1993 in South Asia to that in Sub-Saharan Africa (all income levels)?
Provide a short and direct response. 1.09. What is the difference between the highest and the second highest Total Labor Force (in %) in 1990?
Offer a very short reply. 4.22. What is the difference between the highest and the second highest Total Labor Force (in %) of 1991?
Your response must be concise. 4.46. What is the difference between the highest and the second highest Total Labor Force (in %) in 1992?
Your answer should be compact. 4.7. What is the difference between the highest and the second highest Total Labor Force (in %) of 1993?
Keep it short and to the point. 4.85. What is the difference between the highest and the lowest Total Labor Force (in %) in 1990?
Offer a very short reply. 8.85. What is the difference between the highest and the lowest Total Labor Force (in %) in 1991?
Make the answer very short. 8.73. What is the difference between the highest and the lowest Total Labor Force (in %) of 1992?
Provide a short and direct response. 8.52. What is the difference between the highest and the lowest Total Labor Force (in %) of 1993?
Your answer should be compact. 8.26. 